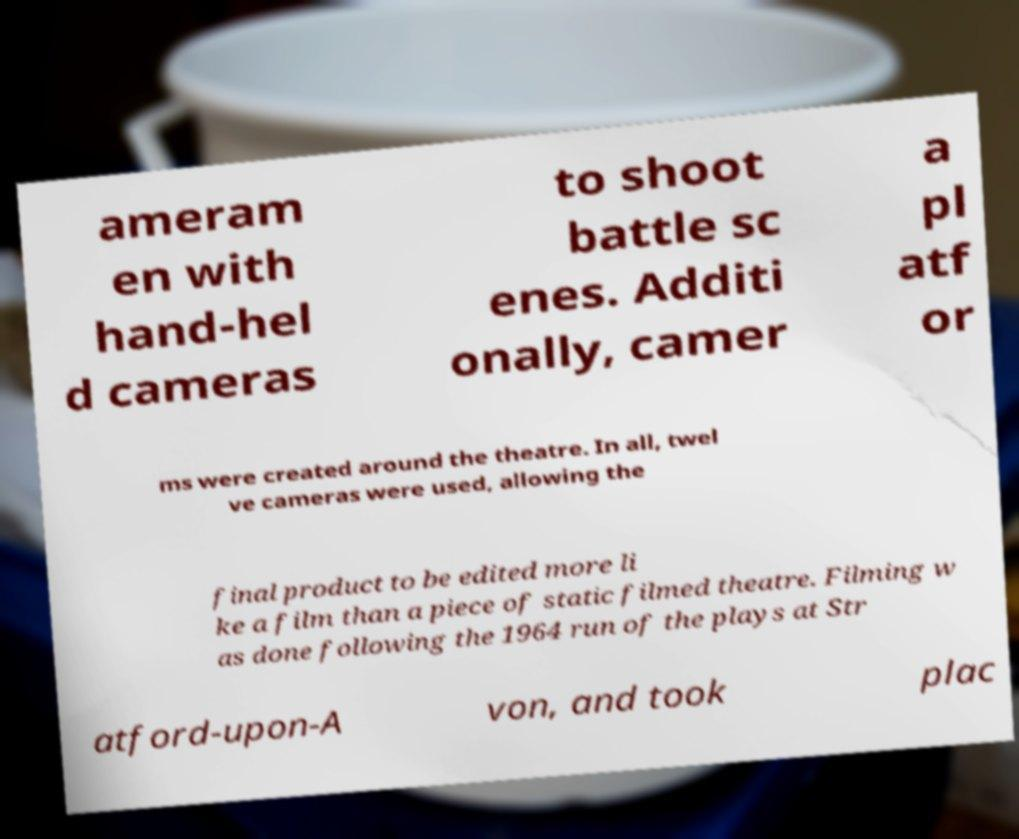For documentation purposes, I need the text within this image transcribed. Could you provide that? ameram en with hand-hel d cameras to shoot battle sc enes. Additi onally, camer a pl atf or ms were created around the theatre. In all, twel ve cameras were used, allowing the final product to be edited more li ke a film than a piece of static filmed theatre. Filming w as done following the 1964 run of the plays at Str atford-upon-A von, and took plac 